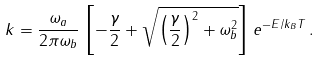Convert formula to latex. <formula><loc_0><loc_0><loc_500><loc_500>k = \frac { \omega _ { a } } { 2 \pi \omega _ { b } } \, \left [ - \frac { \gamma } { 2 } + \sqrt { \left ( \frac { \gamma } { 2 } \right ) ^ { 2 } + \omega _ { b } ^ { 2 } } \right ] \, e ^ { - E / k _ { B } T } \, .</formula> 